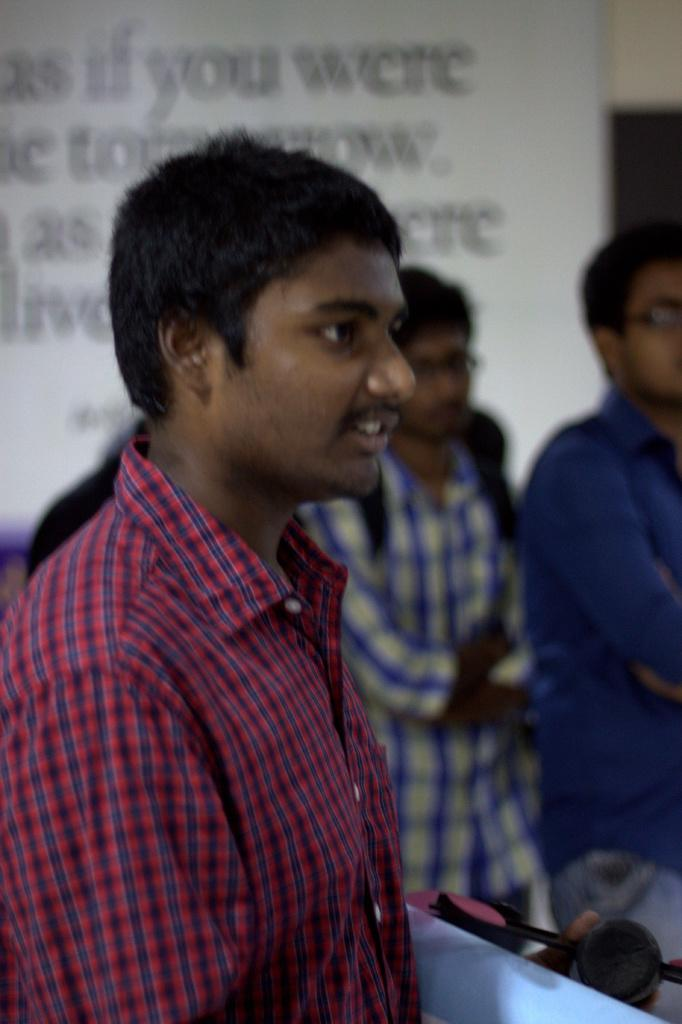How many people are in the image? There are three men standing in the image. What is behind the men in the image? There is a board behind the men. What can be seen on the board? There is text on the board. What type of hospital is depicted in the image? There is no hospital present in the image; it features three men standing in front of a board with text. What rule is being enforced by the house in the image? There is no house or rule mentioned in the image; it only shows three men and a board with text. 